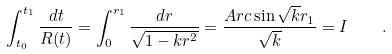Convert formula to latex. <formula><loc_0><loc_0><loc_500><loc_500>\int _ { t _ { 0 } } ^ { t _ { 1 } } \frac { d t } { R ( t ) } = \int _ { 0 } ^ { r _ { 1 } } \frac { d r } { \sqrt { 1 - k { r } ^ { 2 } } } = \frac { A r c \sin \sqrt { k } r _ { 1 } } { \sqrt { k } } = I \quad .</formula> 